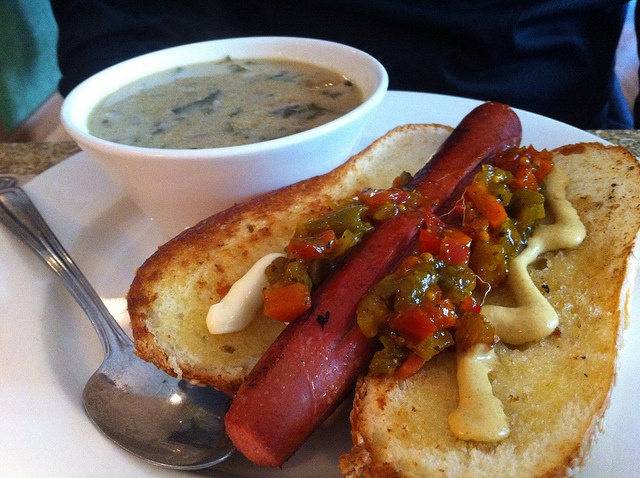Describe the objects in this image and their specific colors. I can see hot dog in black, maroon, olive, and tan tones, people in black and teal tones, bowl in black, darkgray, white, and gray tones, and spoon in black, gray, darkgray, and maroon tones in this image. 